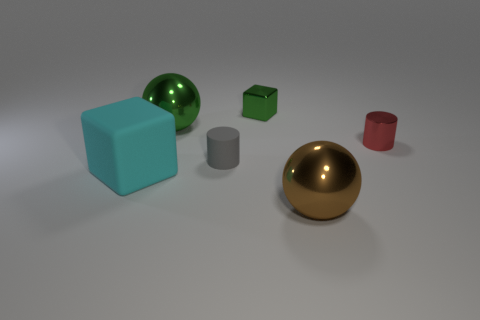Subtract all gray balls. Subtract all cyan cylinders. How many balls are left? 2 Add 3 purple cylinders. How many objects exist? 9 Subtract all blocks. How many objects are left? 4 Subtract all blocks. Subtract all large brown shiny objects. How many objects are left? 3 Add 6 big metallic spheres. How many big metallic spheres are left? 8 Add 2 big blue rubber cubes. How many big blue rubber cubes exist? 2 Subtract 0 gray spheres. How many objects are left? 6 